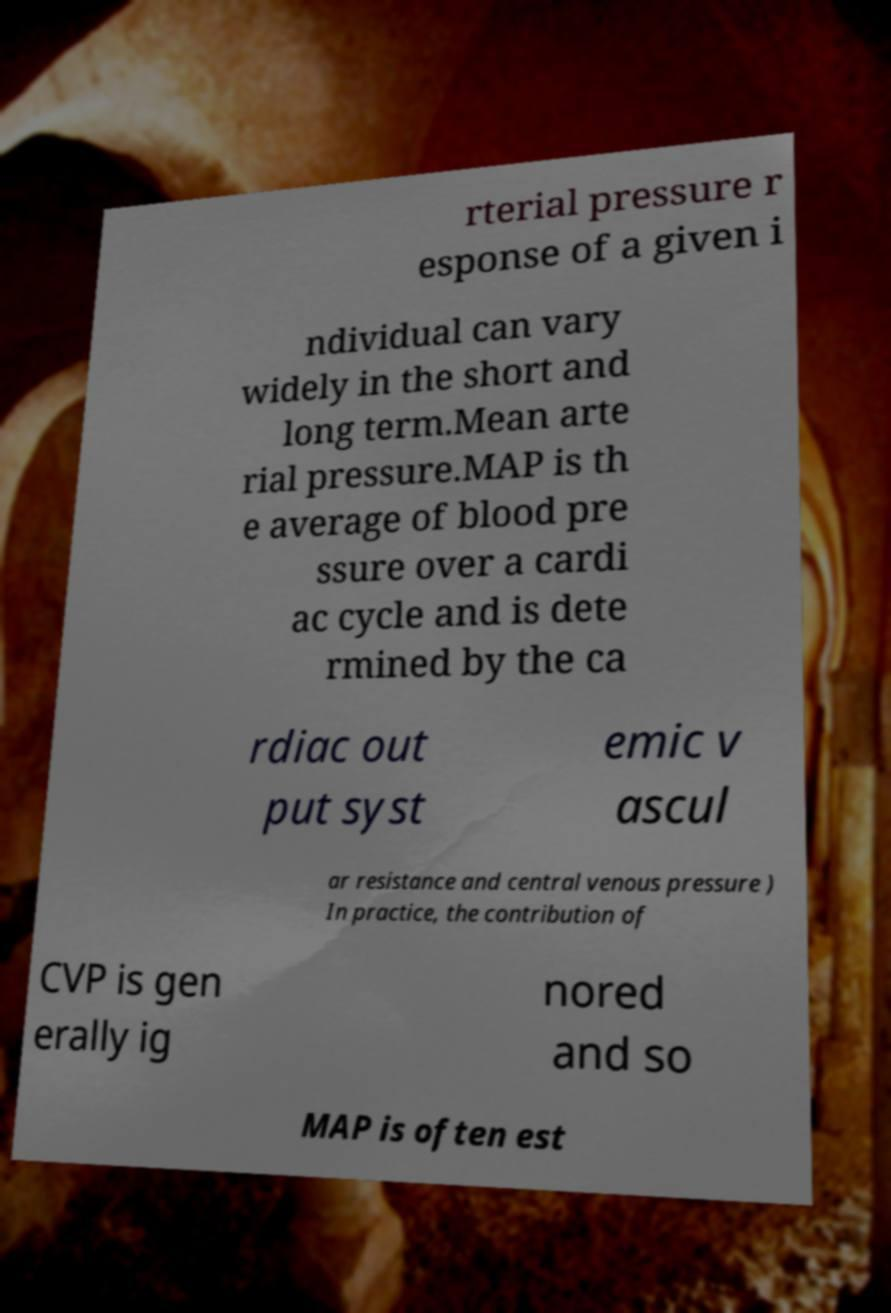For documentation purposes, I need the text within this image transcribed. Could you provide that? rterial pressure r esponse of a given i ndividual can vary widely in the short and long term.Mean arte rial pressure.MAP is th e average of blood pre ssure over a cardi ac cycle and is dete rmined by the ca rdiac out put syst emic v ascul ar resistance and central venous pressure ) In practice, the contribution of CVP is gen erally ig nored and so MAP is often est 